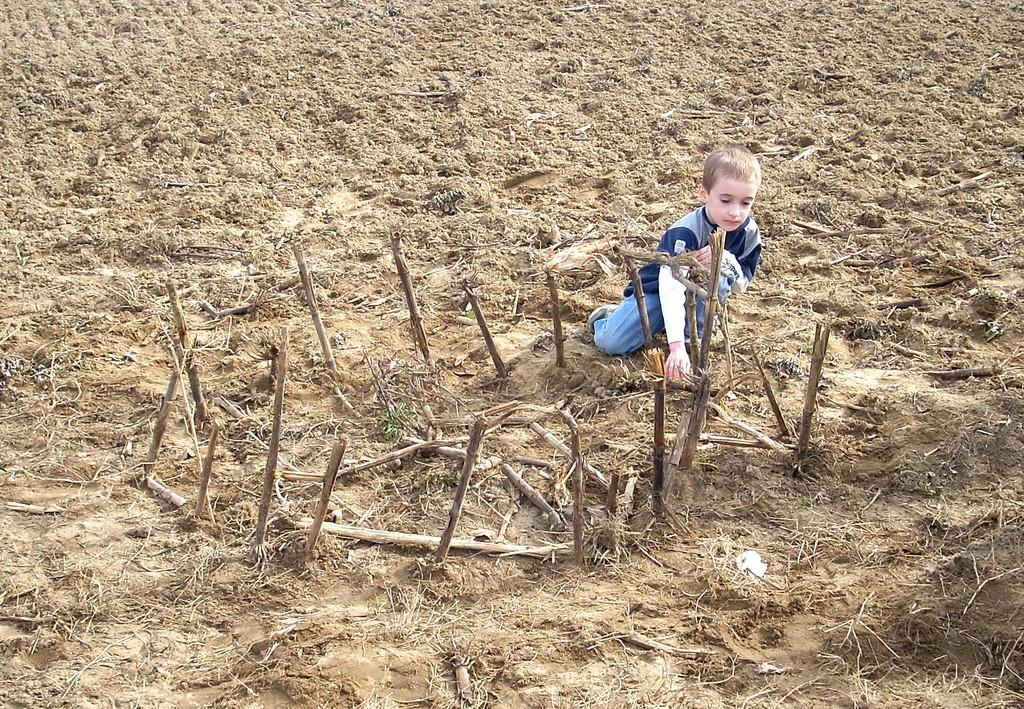Who is the main subject in the image? There is a boy in the image. What is the boy doing in the image? The boy is sitting on the ground. What type of environment is visible in the image? There are woods visible in the image. What type of juice is the boy holding in the image? There is no juice present in the image; the boy is sitting on the ground without any visible objects in his hands. 